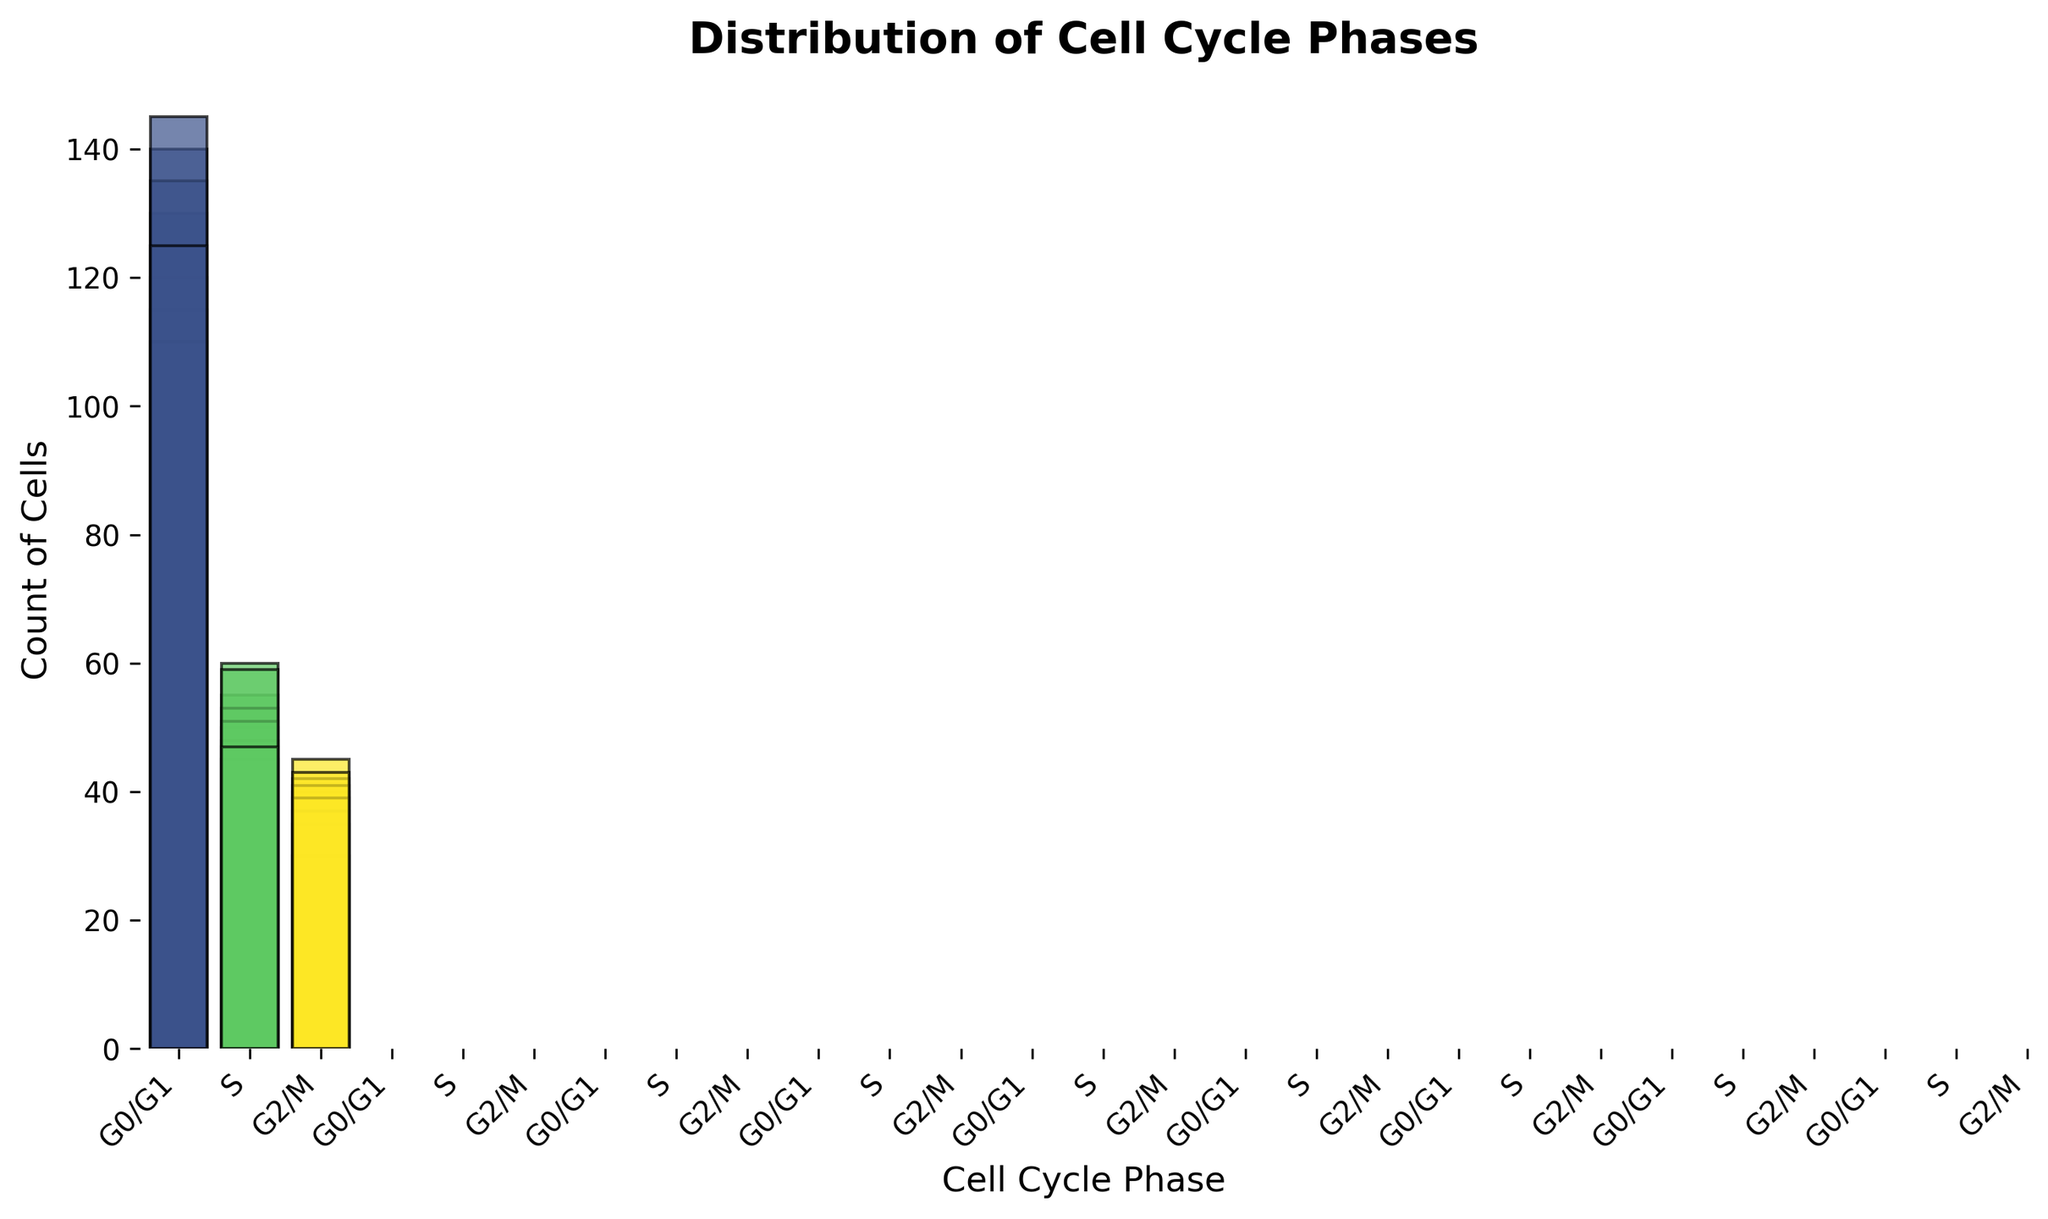What is the total count of cells in the G0/G1 phase? To find the total count of cells in the G0/G1 phase, sum up all the values that correspond to this phase: 120 + 125 + 130 + 115 + 140 + 110 + 135 + 145 + 125 = 1145.
Answer: 1145 Which cell cycle phase has the lowest total count of cells? Compare the total counts for each phase: G0/G1 has 1145, S has 468, and G2/M has 352. The G2/M phase has the lowest total count.
Answer: G2/M What is the average count of cells in the S phase? Sum the counts for the S phase and divide by the number of entries: (45+50+55+60+48+53+51+59+47) / 9 = 468 / 9 = 52.
Answer: 52 How does the maximum count of cells in the G0/G1 phase compare to the maximum count in the G2/M phase? The maximum count in the G0/G1 phase is 145, and in the G2/M phase, it is 45. The G0/G1 phase has a higher maximum count compared to the G2/M phase.
Answer: G0/G1 > G2/M What is the difference between the highest and lowest counts for the G0/G1 phase? Identify the highest count (145) and the lowest count (110) for the G0/G1 phase and find the difference: 145 - 110 = 35.
Answer: 35 Which cell cycle phase has the most variability in cell counts? To determine variability, observe the range (difference between the highest and lowest values): G0/G1 (145-110=35), S (60-45=15), G2/M (45-30=15). Thus, the G0/G1 phase exhibits the most variability.
Answer: G0/G1 How many more cells are there in the G0/G1 phase compared to the G2/M phase in total? Calculate the total count for both phases: G0/G1 (1145), G2/M (352). The difference is 1145 - 352 = 793.
Answer: 793 Is the count of cells in the S phase always greater than or equal to the count of cells in the G2/M phase? Observe the counts for both phases: For each entry, compare the count in the S phase (45, 50, 55, 60, 48, 53, 51, 59, 47) to the G2/M phase (35, 40, 30, 45, 42, 37, 41, 39, 43). The S phase counts are always greater except for the sixth entry where G2/M (45) is slightly higher than S (48). Thus, it is not always true.
Answer: No 